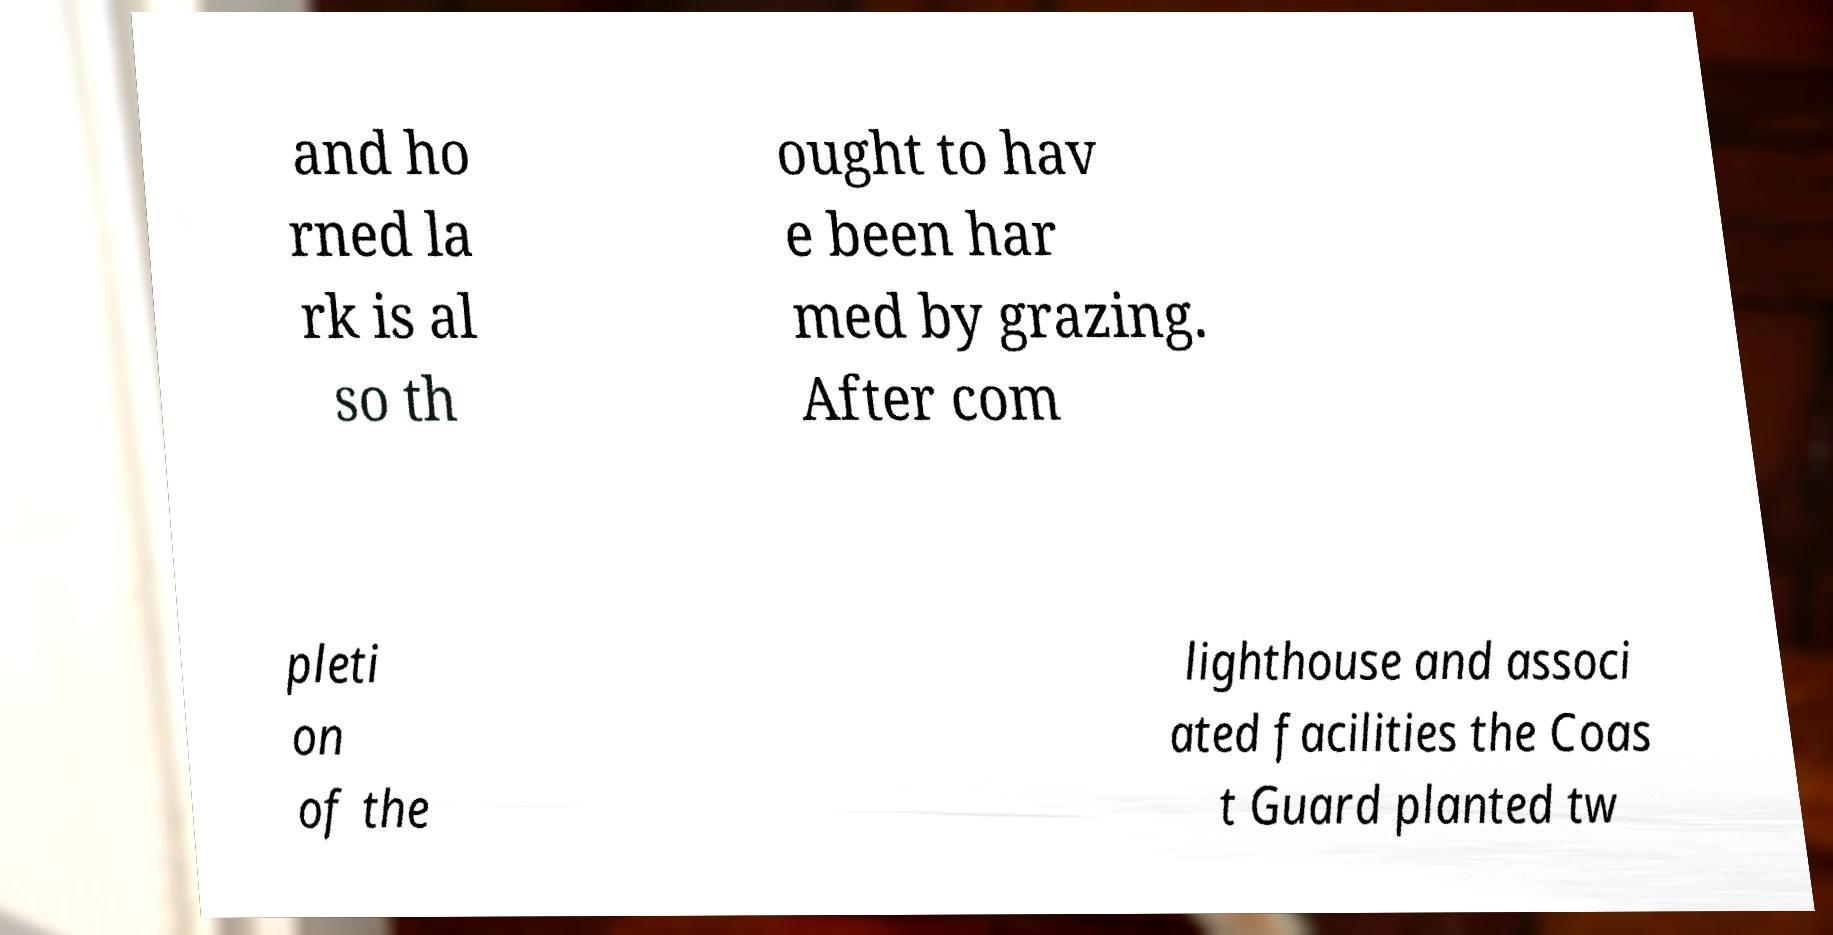I need the written content from this picture converted into text. Can you do that? and ho rned la rk is al so th ought to hav e been har med by grazing. After com pleti on of the lighthouse and associ ated facilities the Coas t Guard planted tw 